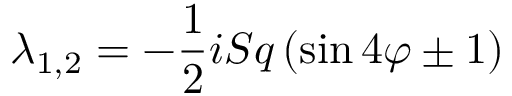Convert formula to latex. <formula><loc_0><loc_0><loc_500><loc_500>\lambda _ { 1 , 2 } = - \frac { 1 } { 2 } i S q \left ( \sin { 4 \varphi } \pm 1 \right )</formula> 